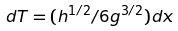Convert formula to latex. <formula><loc_0><loc_0><loc_500><loc_500>d T = ( h ^ { 1 / 2 } / 6 g ^ { 3 / 2 } ) d x</formula> 